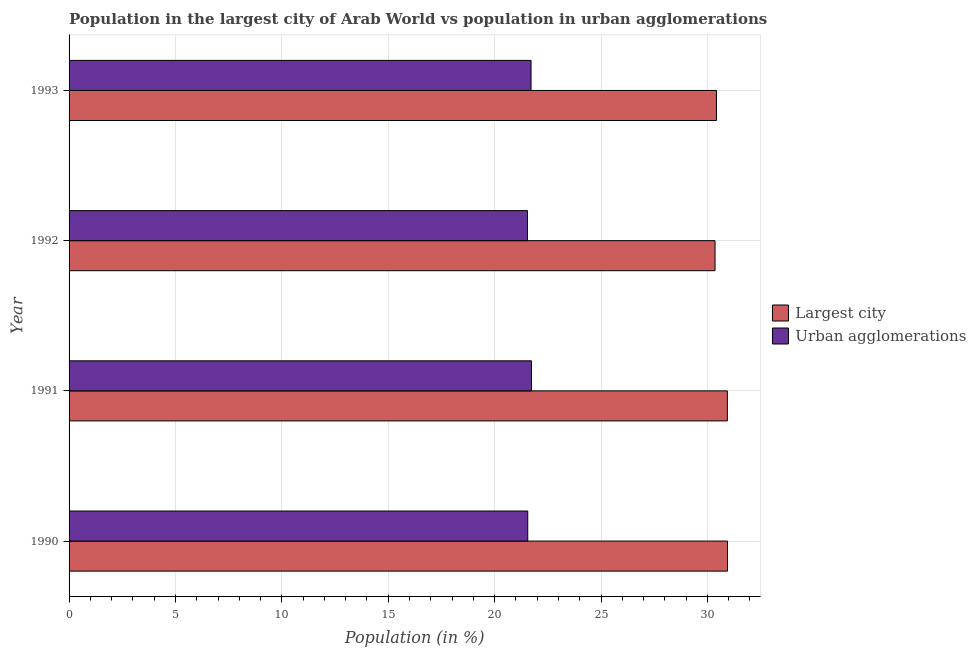Are the number of bars on each tick of the Y-axis equal?
Your answer should be compact. Yes. How many bars are there on the 2nd tick from the top?
Your answer should be very brief. 2. How many bars are there on the 2nd tick from the bottom?
Your answer should be very brief. 2. What is the label of the 2nd group of bars from the top?
Your answer should be compact. 1992. In how many cases, is the number of bars for a given year not equal to the number of legend labels?
Your answer should be very brief. 0. What is the population in the largest city in 1990?
Make the answer very short. 30.95. Across all years, what is the maximum population in urban agglomerations?
Provide a succinct answer. 21.73. Across all years, what is the minimum population in urban agglomerations?
Offer a very short reply. 21.55. In which year was the population in urban agglomerations maximum?
Give a very brief answer. 1991. What is the total population in the largest city in the graph?
Give a very brief answer. 122.67. What is the difference between the population in the largest city in 1992 and that in 1993?
Your response must be concise. -0.07. What is the difference between the population in urban agglomerations in 1990 and the population in the largest city in 1992?
Provide a short and direct response. -8.8. What is the average population in urban agglomerations per year?
Offer a very short reply. 21.64. In the year 1991, what is the difference between the population in urban agglomerations and population in the largest city?
Keep it short and to the point. -9.21. In how many years, is the population in the largest city greater than 5 %?
Your response must be concise. 4. What is the ratio of the population in urban agglomerations in 1990 to that in 1991?
Provide a succinct answer. 0.99. What is the difference between the highest and the second highest population in urban agglomerations?
Offer a very short reply. 0.02. What is the difference between the highest and the lowest population in urban agglomerations?
Your response must be concise. 0.19. Is the sum of the population in the largest city in 1991 and 1992 greater than the maximum population in urban agglomerations across all years?
Provide a succinct answer. Yes. What does the 2nd bar from the top in 1992 represents?
Give a very brief answer. Largest city. What does the 2nd bar from the bottom in 1992 represents?
Give a very brief answer. Urban agglomerations. What is the difference between two consecutive major ticks on the X-axis?
Make the answer very short. 5. Where does the legend appear in the graph?
Your answer should be very brief. Center right. How many legend labels are there?
Your answer should be very brief. 2. What is the title of the graph?
Ensure brevity in your answer.  Population in the largest city of Arab World vs population in urban agglomerations. What is the label or title of the Y-axis?
Provide a succinct answer. Year. What is the Population (in %) of Largest city in 1990?
Ensure brevity in your answer.  30.95. What is the Population (in %) of Urban agglomerations in 1990?
Your response must be concise. 21.56. What is the Population (in %) of Largest city in 1991?
Offer a very short reply. 30.94. What is the Population (in %) of Urban agglomerations in 1991?
Provide a succinct answer. 21.73. What is the Population (in %) of Largest city in 1992?
Your response must be concise. 30.36. What is the Population (in %) of Urban agglomerations in 1992?
Your answer should be very brief. 21.55. What is the Population (in %) of Largest city in 1993?
Make the answer very short. 30.43. What is the Population (in %) of Urban agglomerations in 1993?
Keep it short and to the point. 21.71. Across all years, what is the maximum Population (in %) of Largest city?
Provide a succinct answer. 30.95. Across all years, what is the maximum Population (in %) of Urban agglomerations?
Provide a succinct answer. 21.73. Across all years, what is the minimum Population (in %) of Largest city?
Give a very brief answer. 30.36. Across all years, what is the minimum Population (in %) in Urban agglomerations?
Your answer should be very brief. 21.55. What is the total Population (in %) in Largest city in the graph?
Keep it short and to the point. 122.67. What is the total Population (in %) of Urban agglomerations in the graph?
Make the answer very short. 86.55. What is the difference between the Population (in %) in Largest city in 1990 and that in 1991?
Your answer should be compact. 0.01. What is the difference between the Population (in %) in Urban agglomerations in 1990 and that in 1991?
Ensure brevity in your answer.  -0.18. What is the difference between the Population (in %) in Largest city in 1990 and that in 1992?
Keep it short and to the point. 0.59. What is the difference between the Population (in %) of Urban agglomerations in 1990 and that in 1992?
Your response must be concise. 0.01. What is the difference between the Population (in %) of Largest city in 1990 and that in 1993?
Provide a succinct answer. 0.52. What is the difference between the Population (in %) in Urban agglomerations in 1990 and that in 1993?
Offer a very short reply. -0.16. What is the difference between the Population (in %) in Largest city in 1991 and that in 1992?
Offer a terse response. 0.58. What is the difference between the Population (in %) of Urban agglomerations in 1991 and that in 1992?
Offer a terse response. 0.19. What is the difference between the Population (in %) of Largest city in 1991 and that in 1993?
Offer a very short reply. 0.51. What is the difference between the Population (in %) in Largest city in 1992 and that in 1993?
Ensure brevity in your answer.  -0.07. What is the difference between the Population (in %) of Urban agglomerations in 1992 and that in 1993?
Give a very brief answer. -0.17. What is the difference between the Population (in %) of Largest city in 1990 and the Population (in %) of Urban agglomerations in 1991?
Offer a very short reply. 9.21. What is the difference between the Population (in %) in Largest city in 1990 and the Population (in %) in Urban agglomerations in 1992?
Ensure brevity in your answer.  9.4. What is the difference between the Population (in %) of Largest city in 1990 and the Population (in %) of Urban agglomerations in 1993?
Make the answer very short. 9.23. What is the difference between the Population (in %) of Largest city in 1991 and the Population (in %) of Urban agglomerations in 1992?
Give a very brief answer. 9.39. What is the difference between the Population (in %) in Largest city in 1991 and the Population (in %) in Urban agglomerations in 1993?
Ensure brevity in your answer.  9.23. What is the difference between the Population (in %) of Largest city in 1992 and the Population (in %) of Urban agglomerations in 1993?
Ensure brevity in your answer.  8.65. What is the average Population (in %) in Largest city per year?
Offer a very short reply. 30.67. What is the average Population (in %) in Urban agglomerations per year?
Make the answer very short. 21.64. In the year 1990, what is the difference between the Population (in %) in Largest city and Population (in %) in Urban agglomerations?
Your answer should be compact. 9.39. In the year 1991, what is the difference between the Population (in %) of Largest city and Population (in %) of Urban agglomerations?
Make the answer very short. 9.21. In the year 1992, what is the difference between the Population (in %) of Largest city and Population (in %) of Urban agglomerations?
Offer a very short reply. 8.81. In the year 1993, what is the difference between the Population (in %) of Largest city and Population (in %) of Urban agglomerations?
Your answer should be compact. 8.72. What is the ratio of the Population (in %) in Urban agglomerations in 1990 to that in 1991?
Provide a succinct answer. 0.99. What is the ratio of the Population (in %) in Largest city in 1990 to that in 1992?
Make the answer very short. 1.02. What is the ratio of the Population (in %) in Largest city in 1990 to that in 1993?
Offer a terse response. 1.02. What is the ratio of the Population (in %) in Largest city in 1991 to that in 1992?
Your response must be concise. 1.02. What is the ratio of the Population (in %) in Urban agglomerations in 1991 to that in 1992?
Keep it short and to the point. 1.01. What is the ratio of the Population (in %) in Largest city in 1991 to that in 1993?
Keep it short and to the point. 1.02. What is the ratio of the Population (in %) of Largest city in 1992 to that in 1993?
Your answer should be compact. 1. What is the difference between the highest and the second highest Population (in %) of Largest city?
Your response must be concise. 0.01. What is the difference between the highest and the second highest Population (in %) of Urban agglomerations?
Make the answer very short. 0.02. What is the difference between the highest and the lowest Population (in %) in Largest city?
Keep it short and to the point. 0.59. What is the difference between the highest and the lowest Population (in %) in Urban agglomerations?
Your answer should be very brief. 0.19. 